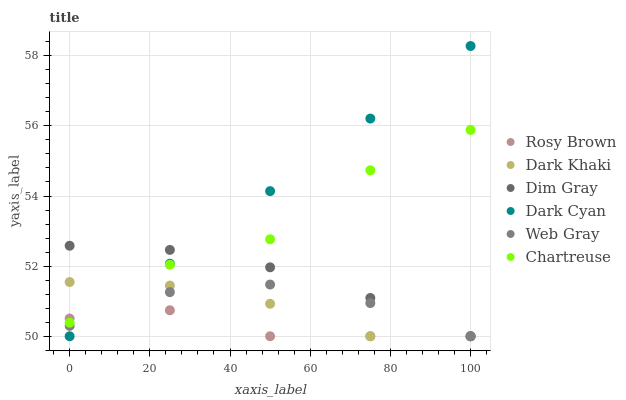Does Rosy Brown have the minimum area under the curve?
Answer yes or no. Yes. Does Dark Cyan have the maximum area under the curve?
Answer yes or no. Yes. Does Dark Khaki have the minimum area under the curve?
Answer yes or no. No. Does Dark Khaki have the maximum area under the curve?
Answer yes or no. No. Is Dark Cyan the smoothest?
Answer yes or no. Yes. Is Chartreuse the roughest?
Answer yes or no. Yes. Is Rosy Brown the smoothest?
Answer yes or no. No. Is Rosy Brown the roughest?
Answer yes or no. No. Does Dim Gray have the lowest value?
Answer yes or no. Yes. Does Chartreuse have the lowest value?
Answer yes or no. No. Does Dark Cyan have the highest value?
Answer yes or no. Yes. Does Dark Khaki have the highest value?
Answer yes or no. No. Is Web Gray less than Chartreuse?
Answer yes or no. Yes. Is Chartreuse greater than Web Gray?
Answer yes or no. Yes. Does Chartreuse intersect Dark Cyan?
Answer yes or no. Yes. Is Chartreuse less than Dark Cyan?
Answer yes or no. No. Is Chartreuse greater than Dark Cyan?
Answer yes or no. No. Does Web Gray intersect Chartreuse?
Answer yes or no. No. 